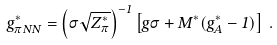<formula> <loc_0><loc_0><loc_500><loc_500>g ^ { * } _ { \pi N N } = \left ( \sigma \sqrt { Z ^ { * } _ { \pi } } \right ) ^ { - 1 } \left [ g \sigma + M ^ { * } ( g ^ { * } _ { A } - 1 ) \right ] \, .</formula> 